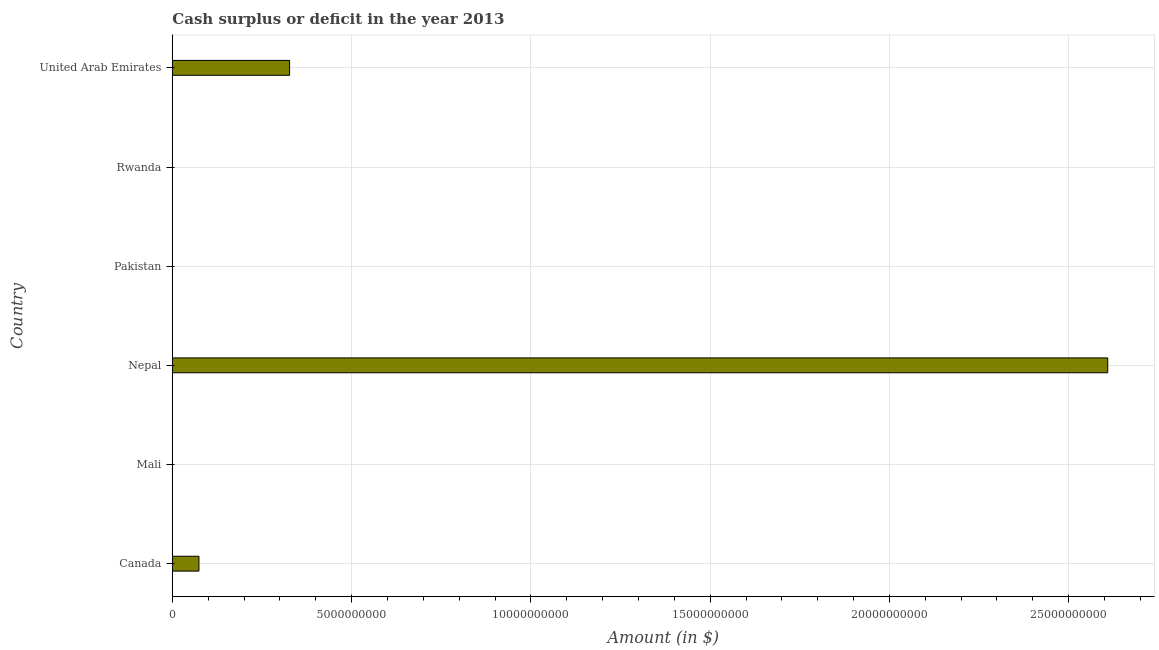Does the graph contain any zero values?
Your answer should be compact. Yes. What is the title of the graph?
Your answer should be very brief. Cash surplus or deficit in the year 2013. What is the label or title of the X-axis?
Ensure brevity in your answer.  Amount (in $). What is the label or title of the Y-axis?
Offer a terse response. Country. What is the cash surplus or deficit in Mali?
Give a very brief answer. 0. Across all countries, what is the maximum cash surplus or deficit?
Ensure brevity in your answer.  2.61e+1. Across all countries, what is the minimum cash surplus or deficit?
Give a very brief answer. 0. In which country was the cash surplus or deficit maximum?
Offer a terse response. Nepal. What is the sum of the cash surplus or deficit?
Make the answer very short. 3.01e+1. What is the difference between the cash surplus or deficit in Canada and United Arab Emirates?
Offer a very short reply. -2.53e+09. What is the average cash surplus or deficit per country?
Keep it short and to the point. 5.02e+09. What is the median cash surplus or deficit?
Keep it short and to the point. 3.71e+08. In how many countries, is the cash surplus or deficit greater than 14000000000 $?
Your response must be concise. 1. What is the ratio of the cash surplus or deficit in Nepal to that in United Arab Emirates?
Provide a short and direct response. 7.98. What is the difference between the highest and the second highest cash surplus or deficit?
Your response must be concise. 2.28e+1. What is the difference between the highest and the lowest cash surplus or deficit?
Offer a very short reply. 2.61e+1. In how many countries, is the cash surplus or deficit greater than the average cash surplus or deficit taken over all countries?
Your answer should be compact. 1. How many bars are there?
Provide a succinct answer. 3. Are all the bars in the graph horizontal?
Provide a short and direct response. Yes. What is the Amount (in $) in Canada?
Keep it short and to the point. 7.42e+08. What is the Amount (in $) in Nepal?
Keep it short and to the point. 2.61e+1. What is the Amount (in $) in Pakistan?
Offer a terse response. 0. What is the Amount (in $) of United Arab Emirates?
Provide a short and direct response. 3.27e+09. What is the difference between the Amount (in $) in Canada and Nepal?
Offer a very short reply. -2.53e+1. What is the difference between the Amount (in $) in Canada and United Arab Emirates?
Ensure brevity in your answer.  -2.53e+09. What is the difference between the Amount (in $) in Nepal and United Arab Emirates?
Your response must be concise. 2.28e+1. What is the ratio of the Amount (in $) in Canada to that in Nepal?
Provide a short and direct response. 0.03. What is the ratio of the Amount (in $) in Canada to that in United Arab Emirates?
Provide a short and direct response. 0.23. What is the ratio of the Amount (in $) in Nepal to that in United Arab Emirates?
Offer a very short reply. 7.98. 